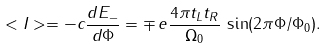<formula> <loc_0><loc_0><loc_500><loc_500>< I > = - c \frac { d E _ { - } } { d \Phi } = \mp \, { e } \frac { 4 \pi t _ { L } t _ { R } } { \Omega _ { 0 } } \, \sin ( 2 \pi \Phi / \Phi _ { 0 } ) .</formula> 